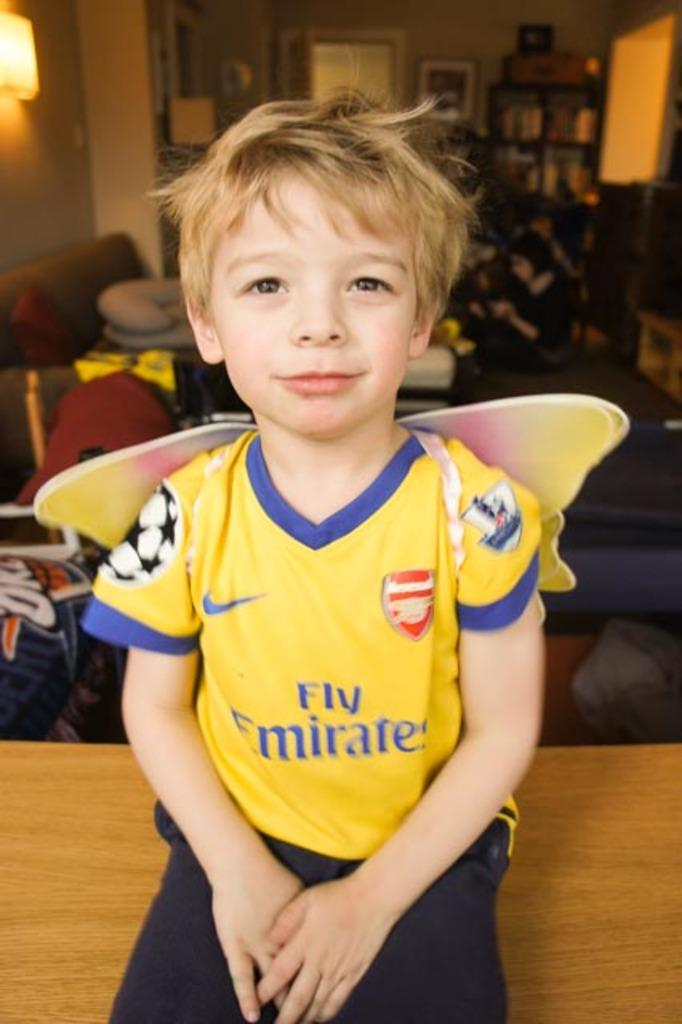<image>
Share a concise interpretation of the image provided. A small boy with a soccer shirt that says "Fly Emirates" on it. 